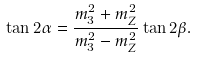Convert formula to latex. <formula><loc_0><loc_0><loc_500><loc_500>\tan 2 \alpha = \frac { m ^ { 2 } _ { 3 } + m ^ { 2 } _ { Z } } { m ^ { 2 } _ { 3 } - m ^ { 2 } _ { Z } } \tan 2 \beta .</formula> 